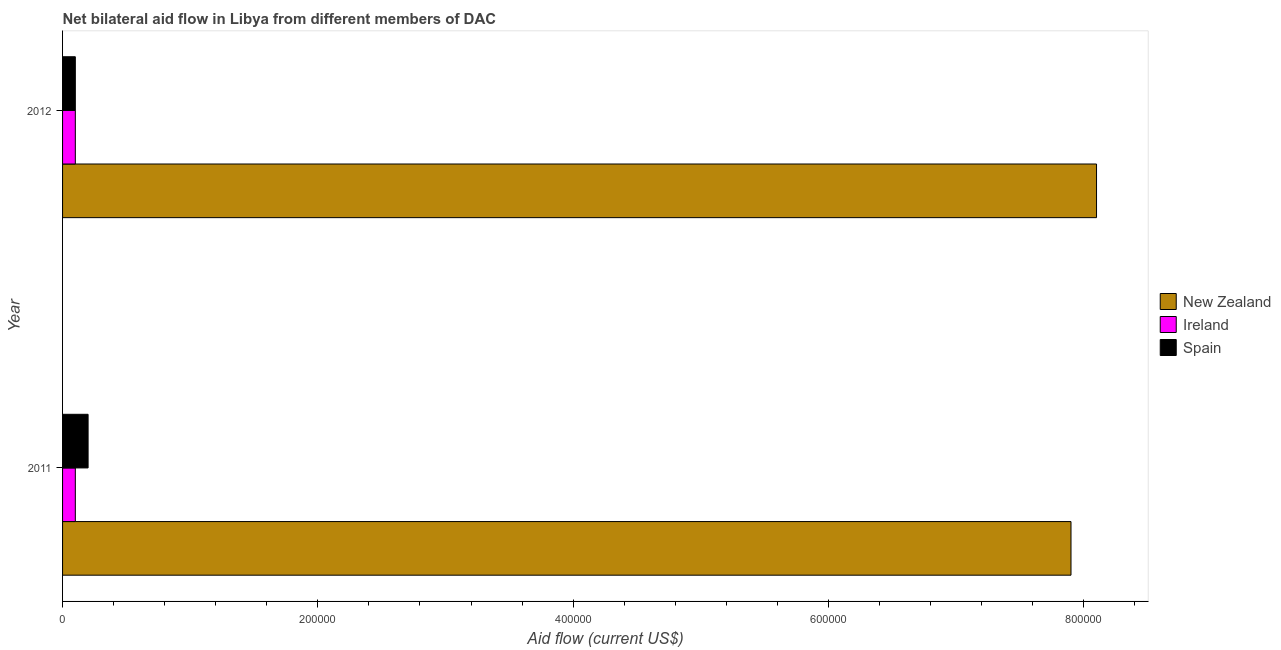How many different coloured bars are there?
Your answer should be very brief. 3. How many groups of bars are there?
Your response must be concise. 2. How many bars are there on the 2nd tick from the bottom?
Your answer should be compact. 3. In how many cases, is the number of bars for a given year not equal to the number of legend labels?
Make the answer very short. 0. What is the amount of aid provided by ireland in 2012?
Ensure brevity in your answer.  10000. Across all years, what is the maximum amount of aid provided by new zealand?
Ensure brevity in your answer.  8.10e+05. Across all years, what is the minimum amount of aid provided by ireland?
Ensure brevity in your answer.  10000. What is the total amount of aid provided by ireland in the graph?
Provide a succinct answer. 2.00e+04. What is the difference between the amount of aid provided by new zealand in 2011 and that in 2012?
Keep it short and to the point. -2.00e+04. What is the difference between the amount of aid provided by spain in 2012 and the amount of aid provided by new zealand in 2011?
Give a very brief answer. -7.80e+05. In the year 2011, what is the difference between the amount of aid provided by ireland and amount of aid provided by spain?
Provide a succinct answer. -10000. What is the ratio of the amount of aid provided by ireland in 2011 to that in 2012?
Make the answer very short. 1. Is the amount of aid provided by spain in 2011 less than that in 2012?
Keep it short and to the point. No. Is the difference between the amount of aid provided by ireland in 2011 and 2012 greater than the difference between the amount of aid provided by spain in 2011 and 2012?
Your answer should be very brief. No. In how many years, is the amount of aid provided by spain greater than the average amount of aid provided by spain taken over all years?
Your answer should be compact. 1. What does the 3rd bar from the top in 2011 represents?
Make the answer very short. New Zealand. What does the 3rd bar from the bottom in 2012 represents?
Offer a very short reply. Spain. Are all the bars in the graph horizontal?
Your answer should be very brief. Yes. What is the difference between two consecutive major ticks on the X-axis?
Offer a terse response. 2.00e+05. Does the graph contain grids?
Offer a terse response. No. Where does the legend appear in the graph?
Your answer should be compact. Center right. How are the legend labels stacked?
Provide a short and direct response. Vertical. What is the title of the graph?
Make the answer very short. Net bilateral aid flow in Libya from different members of DAC. What is the label or title of the X-axis?
Make the answer very short. Aid flow (current US$). What is the label or title of the Y-axis?
Keep it short and to the point. Year. What is the Aid flow (current US$) of New Zealand in 2011?
Ensure brevity in your answer.  7.90e+05. What is the Aid flow (current US$) of New Zealand in 2012?
Offer a terse response. 8.10e+05. What is the Aid flow (current US$) in Ireland in 2012?
Your answer should be compact. 10000. Across all years, what is the maximum Aid flow (current US$) in New Zealand?
Ensure brevity in your answer.  8.10e+05. Across all years, what is the minimum Aid flow (current US$) of New Zealand?
Provide a succinct answer. 7.90e+05. Across all years, what is the minimum Aid flow (current US$) of Ireland?
Your answer should be compact. 10000. What is the total Aid flow (current US$) in New Zealand in the graph?
Offer a very short reply. 1.60e+06. What is the total Aid flow (current US$) of Ireland in the graph?
Provide a succinct answer. 2.00e+04. What is the total Aid flow (current US$) of Spain in the graph?
Provide a short and direct response. 3.00e+04. What is the difference between the Aid flow (current US$) in New Zealand in 2011 and that in 2012?
Offer a terse response. -2.00e+04. What is the difference between the Aid flow (current US$) of Spain in 2011 and that in 2012?
Offer a terse response. 10000. What is the difference between the Aid flow (current US$) of New Zealand in 2011 and the Aid flow (current US$) of Ireland in 2012?
Offer a very short reply. 7.80e+05. What is the difference between the Aid flow (current US$) of New Zealand in 2011 and the Aid flow (current US$) of Spain in 2012?
Make the answer very short. 7.80e+05. What is the difference between the Aid flow (current US$) of Ireland in 2011 and the Aid flow (current US$) of Spain in 2012?
Provide a succinct answer. 0. What is the average Aid flow (current US$) in New Zealand per year?
Keep it short and to the point. 8.00e+05. What is the average Aid flow (current US$) of Ireland per year?
Your answer should be very brief. 10000. What is the average Aid flow (current US$) in Spain per year?
Your response must be concise. 1.50e+04. In the year 2011, what is the difference between the Aid flow (current US$) of New Zealand and Aid flow (current US$) of Ireland?
Ensure brevity in your answer.  7.80e+05. In the year 2011, what is the difference between the Aid flow (current US$) in New Zealand and Aid flow (current US$) in Spain?
Provide a succinct answer. 7.70e+05. In the year 2011, what is the difference between the Aid flow (current US$) in Ireland and Aid flow (current US$) in Spain?
Keep it short and to the point. -10000. In the year 2012, what is the difference between the Aid flow (current US$) in New Zealand and Aid flow (current US$) in Ireland?
Make the answer very short. 8.00e+05. In the year 2012, what is the difference between the Aid flow (current US$) in Ireland and Aid flow (current US$) in Spain?
Give a very brief answer. 0. What is the ratio of the Aid flow (current US$) in New Zealand in 2011 to that in 2012?
Provide a succinct answer. 0.98. What is the ratio of the Aid flow (current US$) in Ireland in 2011 to that in 2012?
Give a very brief answer. 1. What is the difference between the highest and the second highest Aid flow (current US$) of Ireland?
Your answer should be very brief. 0. What is the difference between the highest and the second highest Aid flow (current US$) of Spain?
Make the answer very short. 10000. What is the difference between the highest and the lowest Aid flow (current US$) in New Zealand?
Ensure brevity in your answer.  2.00e+04. What is the difference between the highest and the lowest Aid flow (current US$) of Ireland?
Provide a succinct answer. 0. What is the difference between the highest and the lowest Aid flow (current US$) of Spain?
Keep it short and to the point. 10000. 